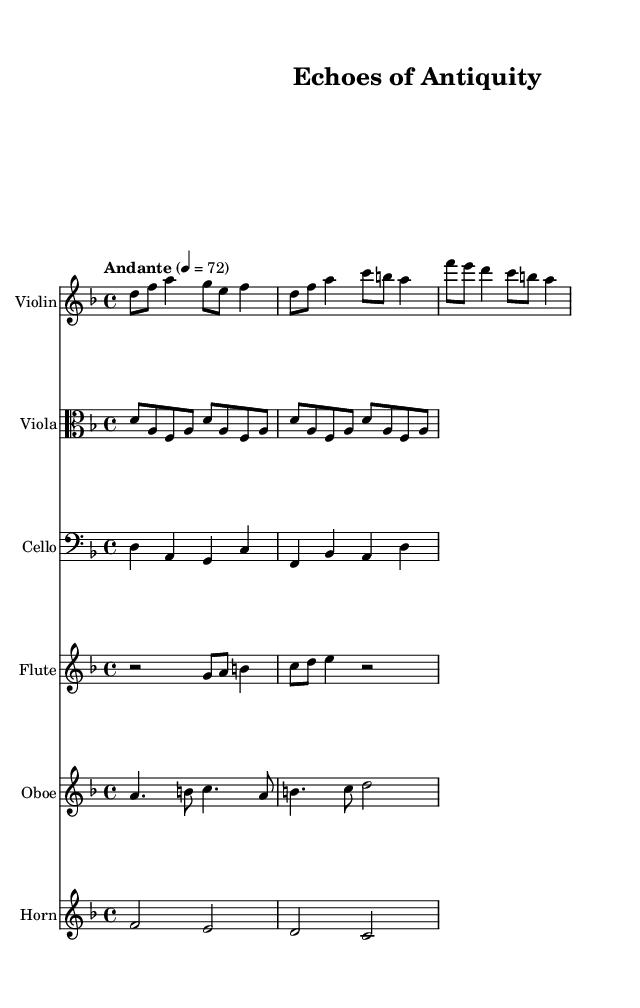What is the time signature of this music? The time signature is found at the beginning of the score, indicated by the symbols following the key signature. In this case, it shows four beats per measure, represented as 4/4.
Answer: 4/4 What is the key signature of this music? The key signature is indicated by the sharps or flats at the beginning of each staff. In this piece, there are no sharps or flats shown, which indicates that the key signature is D minor.
Answer: D minor What is the tempo marking for this piece? The tempo marking is typically written above the staff near the beginning of the score. Here, it indicates a guiding speed of Andante, at a rate of 72 beats per minute.
Answer: Andante Which instruments are featured in this composition? The instruments can be identified by their respective staff labels at the beginning of each staff in the score. This piece features Violin, Viola, Cello, Flute, Oboe, and Horn.
Answer: Violin, Viola, Cello, Flute, Oboe, Horn How many measures are there in the main theme? The main theme is discerned from the initial section of the Violin staff. Counting the distinct sets of four beats gives us a total of four measures.
Answer: Four What is the primary harmonic support instrument in this arrangement? To identify the primary harmonic support in this piece, look for the instrument that provides consistent harmonic foundations throughout the score. The French Horn plays harmonic support, particularly in the later sections.
Answer: French Horn What kind of melody does the Flute part provide? The flute is noted for adding a form of melody that is typically higher than the harmonics. Analyzing the notes in the flute part reveals that it provides a partial melody that complements the main theme.
Answer: Partial melody 